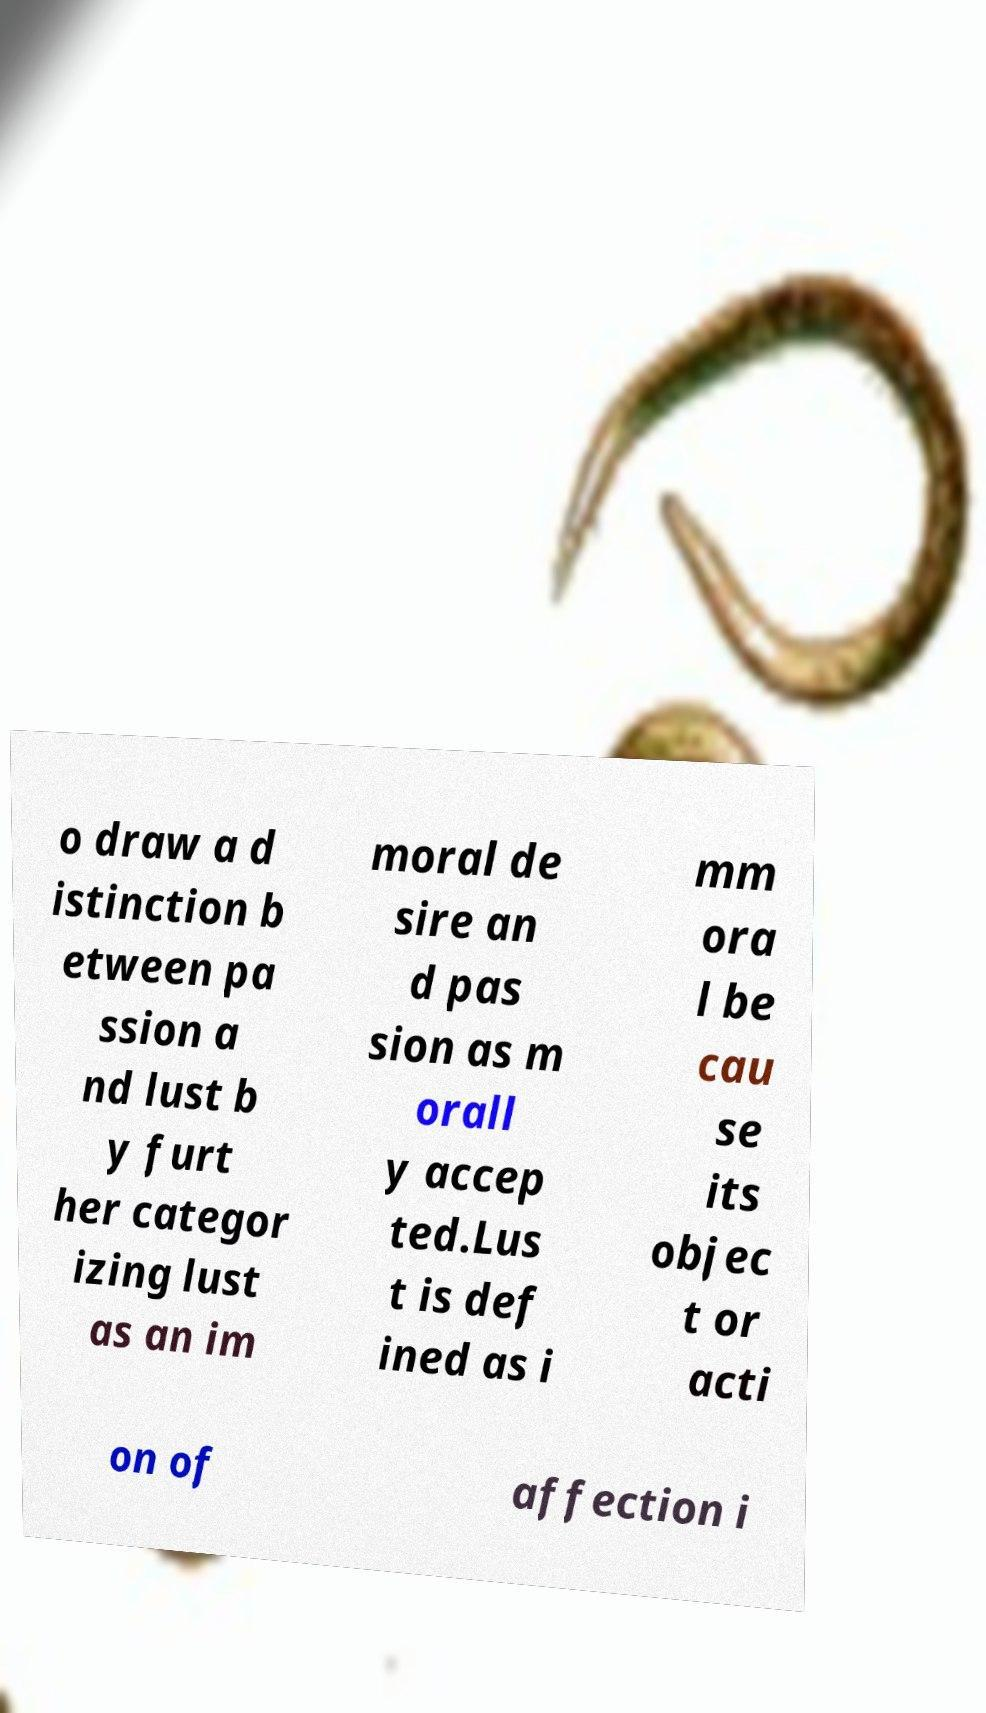Could you assist in decoding the text presented in this image and type it out clearly? o draw a d istinction b etween pa ssion a nd lust b y furt her categor izing lust as an im moral de sire an d pas sion as m orall y accep ted.Lus t is def ined as i mm ora l be cau se its objec t or acti on of affection i 